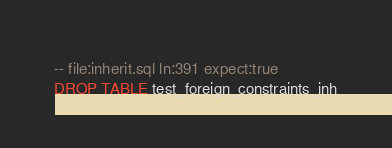Convert code to text. <code><loc_0><loc_0><loc_500><loc_500><_SQL_>-- file:inherit.sql ln:391 expect:true
DROP TABLE test_foreign_constraints_inh
</code> 